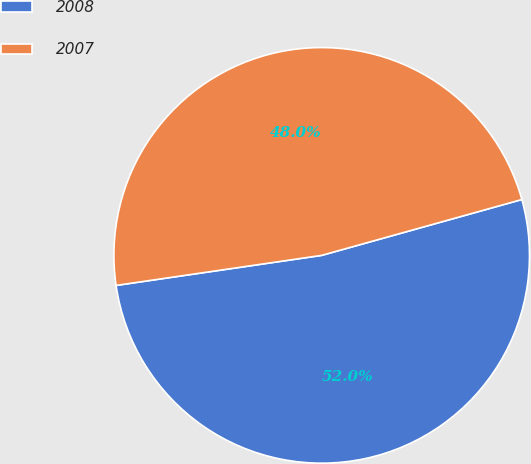Convert chart to OTSL. <chart><loc_0><loc_0><loc_500><loc_500><pie_chart><fcel>2008<fcel>2007<nl><fcel>52.02%<fcel>47.98%<nl></chart> 